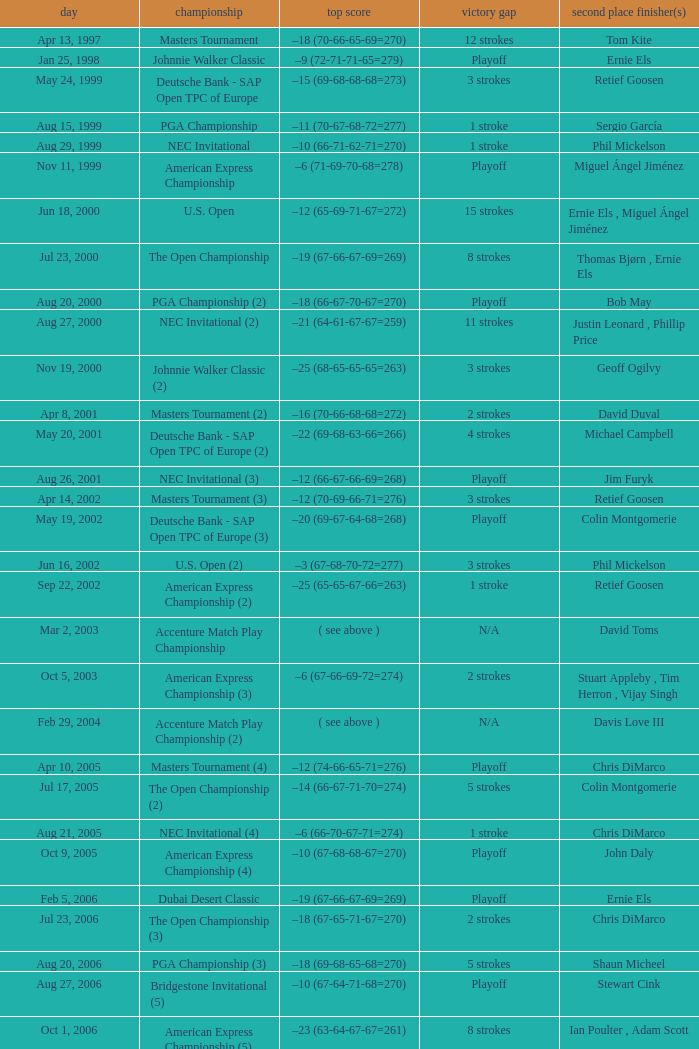Who has the Winning score of –10 (66-71-62-71=270) ? Phil Mickelson. 